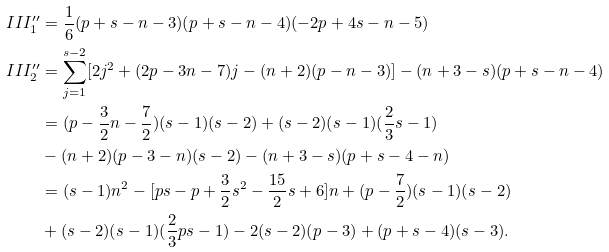<formula> <loc_0><loc_0><loc_500><loc_500>I I I ^ { \prime \prime } _ { 1 } & = \frac { 1 } { 6 } ( p + s - n - 3 ) ( p + s - n - 4 ) ( - 2 p + 4 s - n - 5 ) \\ I I I ^ { \prime \prime } _ { 2 } & = \sum _ { j = 1 } ^ { s - 2 } [ 2 j ^ { 2 } + ( 2 p - 3 n - 7 ) j - ( n + 2 ) ( p - n - 3 ) ] - ( n + 3 - s ) ( p + s - n - 4 ) \\ & = ( p - \frac { 3 } { 2 } n - \frac { 7 } { 2 } ) ( s - 1 ) ( s - 2 ) + ( s - 2 ) ( s - 1 ) ( \frac { 2 } { 3 } s - 1 ) \\ & - ( n + 2 ) ( p - 3 - n ) ( s - 2 ) - ( n + 3 - s ) ( p + s - 4 - n ) \\ & = ( s - 1 ) n ^ { 2 } - [ p s - p + \frac { 3 } { 2 } s ^ { 2 } - \frac { 1 5 } 2 s + 6 ] n + ( p - \frac { 7 } { 2 } ) ( s - 1 ) ( s - 2 ) \\ & + ( s - 2 ) ( s - 1 ) ( \frac { 2 } { 3 } p s - 1 ) - 2 ( s - 2 ) ( p - 3 ) + ( p + s - 4 ) ( s - 3 ) .</formula> 